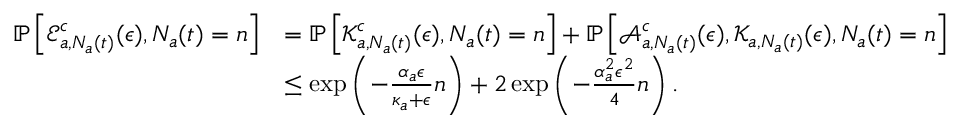<formula> <loc_0><loc_0><loc_500><loc_500>\begin{array} { r l } { \mathbb { P } \left [ \mathcal { E } _ { a , N _ { a } ( t ) } ^ { c } ( \epsilon ) , N _ { a } ( t ) = n \right ] } & { = \mathbb { P } \left [ \mathcal { K } _ { a , N _ { a } ( t ) } ^ { c } ( \epsilon ) , N _ { a } ( t ) = n \right ] + \mathbb { P } \left [ \mathcal { A } _ { a , N _ { a } ( t ) } ^ { c } ( \epsilon ) , \mathcal { K } _ { a , N _ { a } ( t ) } ( \epsilon ) , N _ { a } ( t ) = n \right ] } \\ & { \leq \exp \left ( - \frac { \alpha _ { a } \epsilon } { \kappa _ { a } + \epsilon } n \right ) + 2 \exp \left ( - \frac { \alpha _ { a } ^ { 2 } \epsilon ^ { 2 } } { 4 } n \right ) . } \end{array}</formula> 